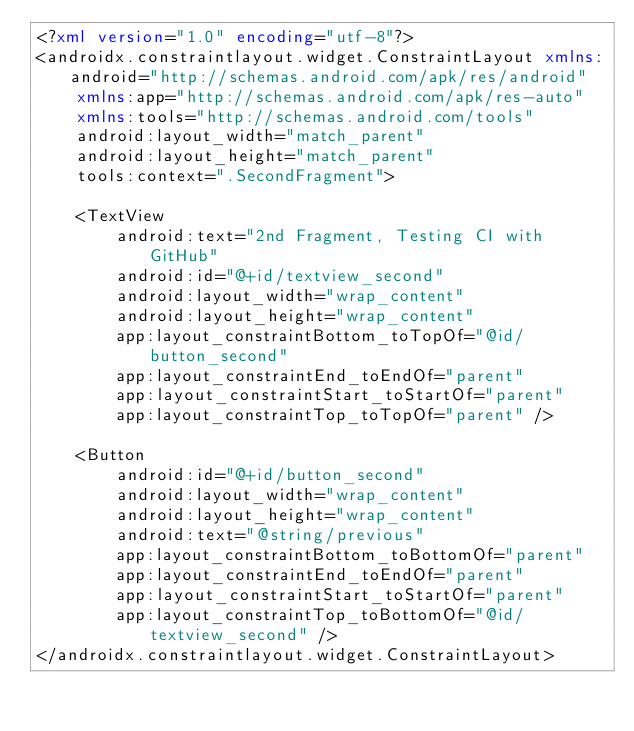<code> <loc_0><loc_0><loc_500><loc_500><_XML_><?xml version="1.0" encoding="utf-8"?>
<androidx.constraintlayout.widget.ConstraintLayout xmlns:android="http://schemas.android.com/apk/res/android"
    xmlns:app="http://schemas.android.com/apk/res-auto"
    xmlns:tools="http://schemas.android.com/tools"
    android:layout_width="match_parent"
    android:layout_height="match_parent"
    tools:context=".SecondFragment">

    <TextView
        android:text="2nd Fragment, Testing CI with GitHub"
        android:id="@+id/textview_second"
        android:layout_width="wrap_content"
        android:layout_height="wrap_content"
        app:layout_constraintBottom_toTopOf="@id/button_second"
        app:layout_constraintEnd_toEndOf="parent"
        app:layout_constraintStart_toStartOf="parent"
        app:layout_constraintTop_toTopOf="parent" />

    <Button
        android:id="@+id/button_second"
        android:layout_width="wrap_content"
        android:layout_height="wrap_content"
        android:text="@string/previous"
        app:layout_constraintBottom_toBottomOf="parent"
        app:layout_constraintEnd_toEndOf="parent"
        app:layout_constraintStart_toStartOf="parent"
        app:layout_constraintTop_toBottomOf="@id/textview_second" />
</androidx.constraintlayout.widget.ConstraintLayout></code> 